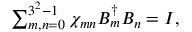<formula> <loc_0><loc_0><loc_500><loc_500>\begin{array} { r } { \sum _ { m , n = 0 } ^ { 3 ^ { 2 } - 1 } \chi _ { m n } B _ { m } ^ { \dagger } B _ { n } = I , } \end{array}</formula> 